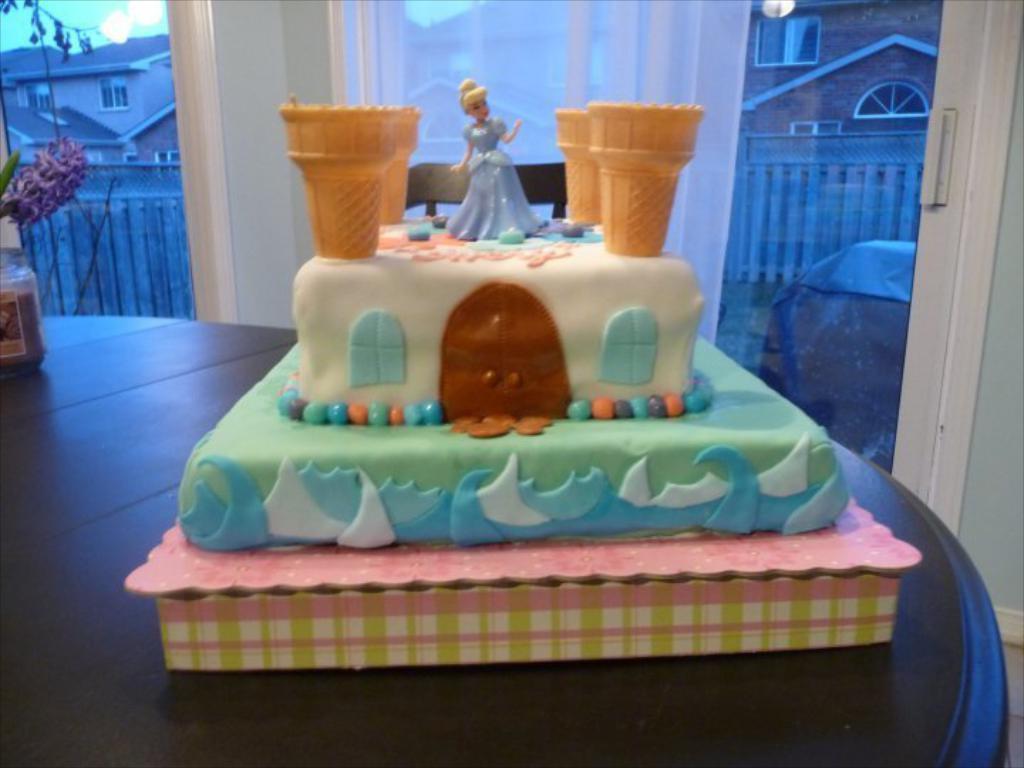Describe this image in one or two sentences. In this picture we can see a cake on the table. Here we can see a jar. On the cake we can see ice cream cone, doll and house design. In the background we can see many buildings. Here we can see fencing. On the top left corner there is a sky. Here we can see leaves. On the right we can see couch near to the door. 